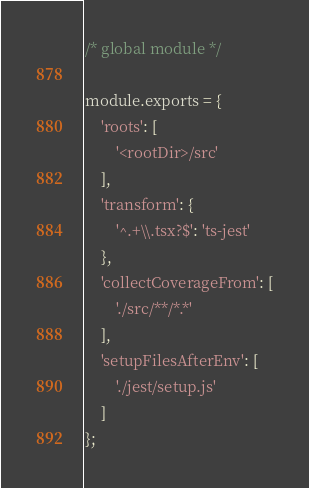Convert code to text. <code><loc_0><loc_0><loc_500><loc_500><_JavaScript_>/* global module */

module.exports = {
    'roots': [
        '<rootDir>/src'
    ],
    'transform': {
        '^.+\\.tsx?$': 'ts-jest'
    },
    'collectCoverageFrom': [
        './src/**/*.*'
    ],
    'setupFilesAfterEnv': [
        './jest/setup.js'
    ]
};
</code> 